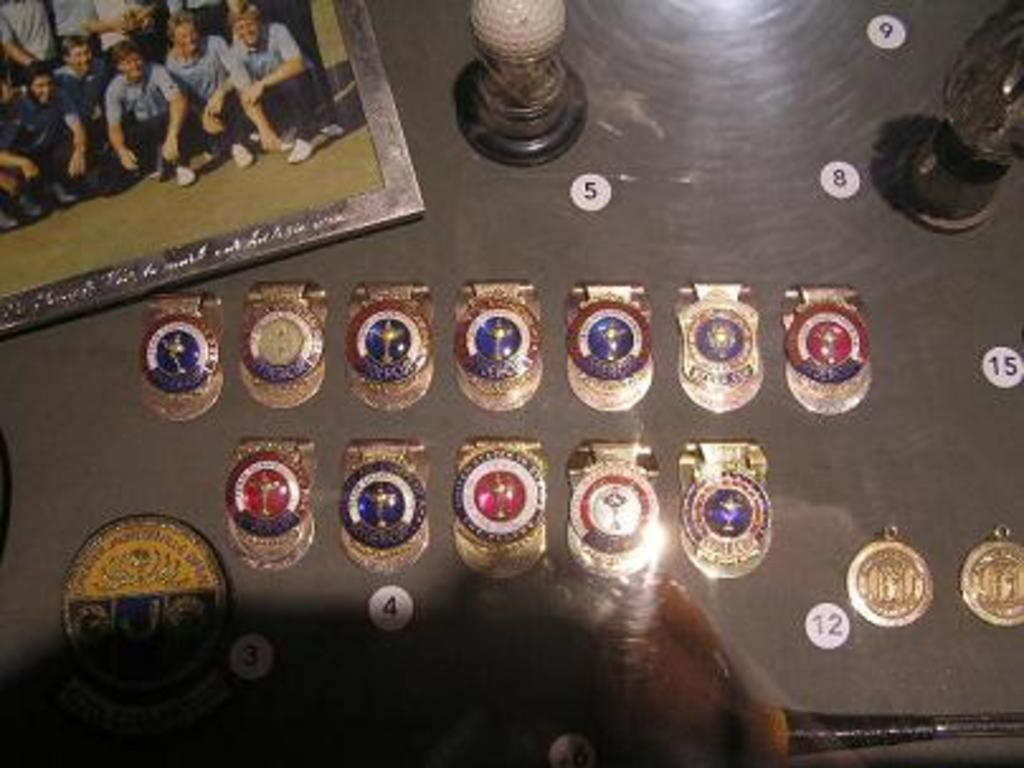Provide a one-sentence caption for the provided image. A table with numbers visible on it - five and eight are two of these. 